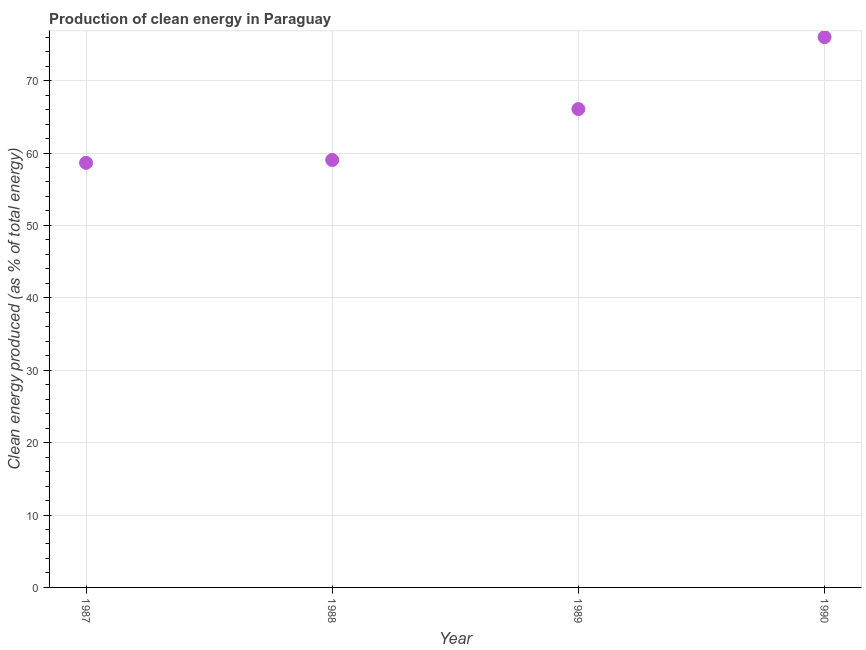What is the production of clean energy in 1990?
Provide a succinct answer. 76.01. Across all years, what is the maximum production of clean energy?
Your response must be concise. 76.01. Across all years, what is the minimum production of clean energy?
Offer a very short reply. 58.65. In which year was the production of clean energy maximum?
Make the answer very short. 1990. What is the sum of the production of clean energy?
Provide a short and direct response. 259.78. What is the difference between the production of clean energy in 1988 and 1989?
Offer a very short reply. -7.03. What is the average production of clean energy per year?
Your answer should be very brief. 64.94. What is the median production of clean energy?
Your response must be concise. 62.56. In how many years, is the production of clean energy greater than 32 %?
Your answer should be compact. 4. Do a majority of the years between 1990 and 1988 (inclusive) have production of clean energy greater than 46 %?
Provide a succinct answer. No. What is the ratio of the production of clean energy in 1988 to that in 1989?
Your answer should be compact. 0.89. Is the production of clean energy in 1989 less than that in 1990?
Keep it short and to the point. Yes. What is the difference between the highest and the second highest production of clean energy?
Your answer should be very brief. 9.94. Is the sum of the production of clean energy in 1987 and 1989 greater than the maximum production of clean energy across all years?
Make the answer very short. Yes. What is the difference between the highest and the lowest production of clean energy?
Offer a very short reply. 17.36. How many dotlines are there?
Provide a short and direct response. 1. How many years are there in the graph?
Give a very brief answer. 4. What is the difference between two consecutive major ticks on the Y-axis?
Give a very brief answer. 10. Are the values on the major ticks of Y-axis written in scientific E-notation?
Offer a very short reply. No. Does the graph contain any zero values?
Provide a succinct answer. No. What is the title of the graph?
Offer a very short reply. Production of clean energy in Paraguay. What is the label or title of the X-axis?
Your answer should be very brief. Year. What is the label or title of the Y-axis?
Offer a very short reply. Clean energy produced (as % of total energy). What is the Clean energy produced (as % of total energy) in 1987?
Make the answer very short. 58.65. What is the Clean energy produced (as % of total energy) in 1988?
Provide a succinct answer. 59.04. What is the Clean energy produced (as % of total energy) in 1989?
Your answer should be very brief. 66.08. What is the Clean energy produced (as % of total energy) in 1990?
Your answer should be very brief. 76.01. What is the difference between the Clean energy produced (as % of total energy) in 1987 and 1988?
Give a very brief answer. -0.39. What is the difference between the Clean energy produced (as % of total energy) in 1987 and 1989?
Make the answer very short. -7.43. What is the difference between the Clean energy produced (as % of total energy) in 1987 and 1990?
Make the answer very short. -17.36. What is the difference between the Clean energy produced (as % of total energy) in 1988 and 1989?
Provide a succinct answer. -7.03. What is the difference between the Clean energy produced (as % of total energy) in 1988 and 1990?
Your response must be concise. -16.97. What is the difference between the Clean energy produced (as % of total energy) in 1989 and 1990?
Your answer should be very brief. -9.94. What is the ratio of the Clean energy produced (as % of total energy) in 1987 to that in 1989?
Ensure brevity in your answer.  0.89. What is the ratio of the Clean energy produced (as % of total energy) in 1987 to that in 1990?
Your answer should be compact. 0.77. What is the ratio of the Clean energy produced (as % of total energy) in 1988 to that in 1989?
Your answer should be very brief. 0.89. What is the ratio of the Clean energy produced (as % of total energy) in 1988 to that in 1990?
Offer a very short reply. 0.78. What is the ratio of the Clean energy produced (as % of total energy) in 1989 to that in 1990?
Your answer should be very brief. 0.87. 